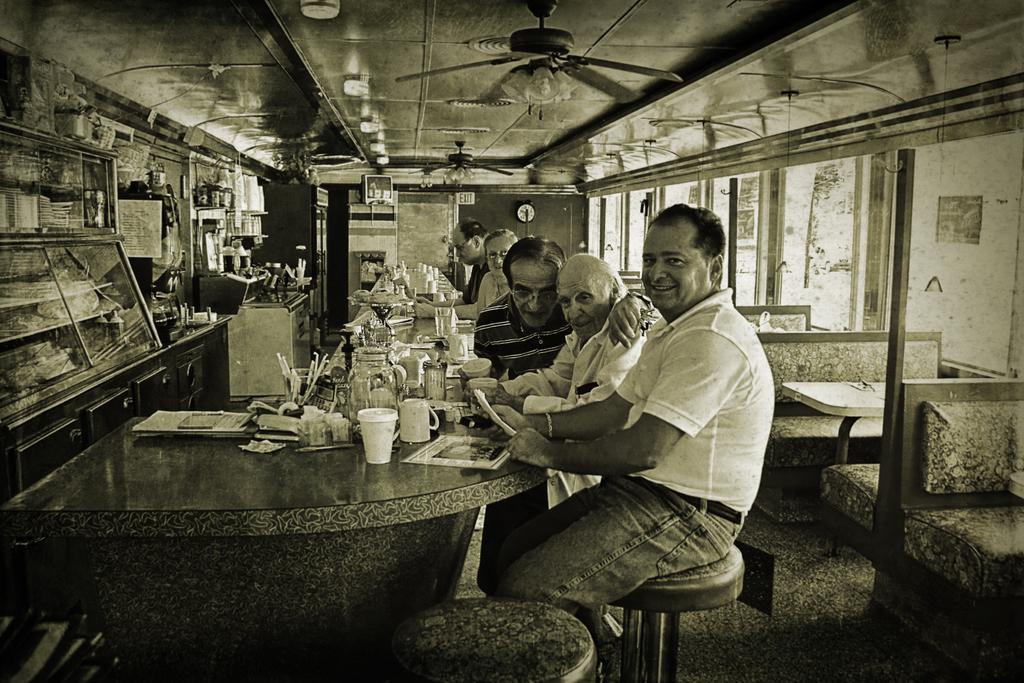In one or two sentences, can you explain what this image depicts? There is a man in white color t-shirt, laughing and sitting on a stool. In front of him, there is a table. there are glasses, jugs and items on it. Beside him, other people some of them are sitting and remaining are standing. In the background, there is a fan, clock, glass, chairs,. On the left hand side, there is glass, cupboard and shelves. 